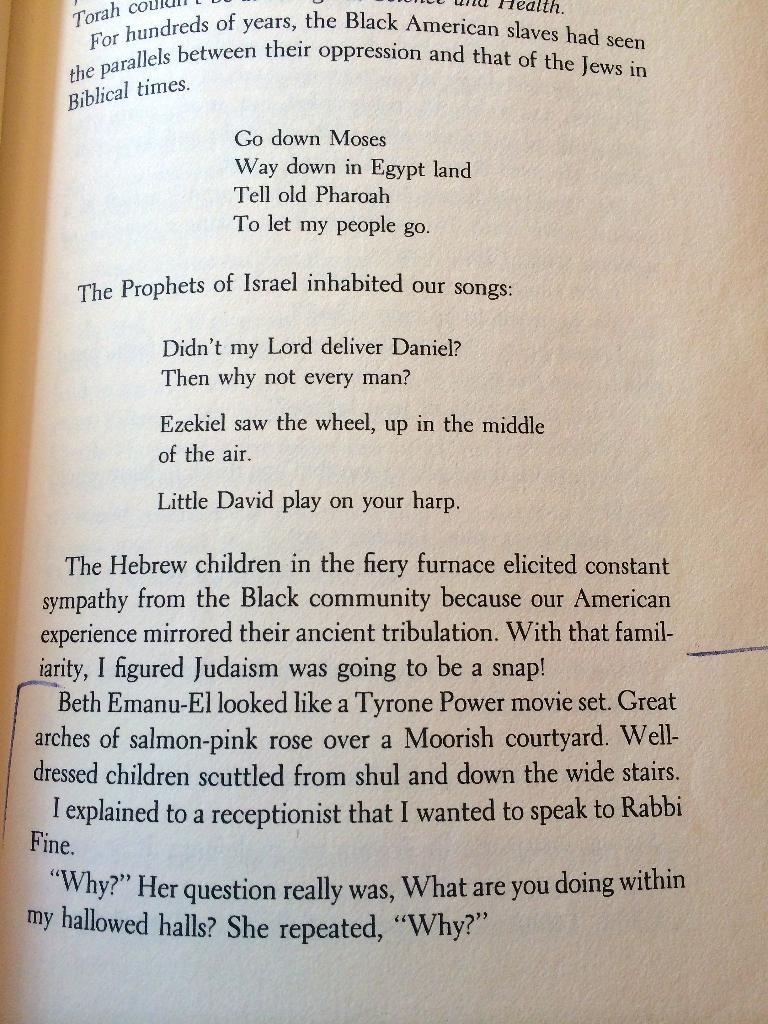What inhabited their songs?
Provide a short and direct response. The prophets of israel. 